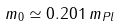<formula> <loc_0><loc_0><loc_500><loc_500>m _ { 0 } \simeq 0 . 2 0 1 \, m _ { P l }</formula> 